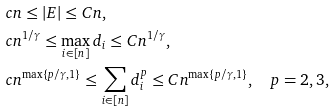Convert formula to latex. <formula><loc_0><loc_0><loc_500><loc_500>& c n \leq | E | \leq C n , \\ & c n ^ { 1 / \gamma } \leq \max _ { i \in [ n ] } d _ { i } \leq C n ^ { 1 / \gamma } , \\ & c n ^ { \max \{ p / \gamma , 1 \} } \leq \sum _ { i \in [ n ] } d _ { i } ^ { p } \leq C n ^ { \max \{ p / \gamma , 1 \} } , \quad p = 2 , 3 ,</formula> 